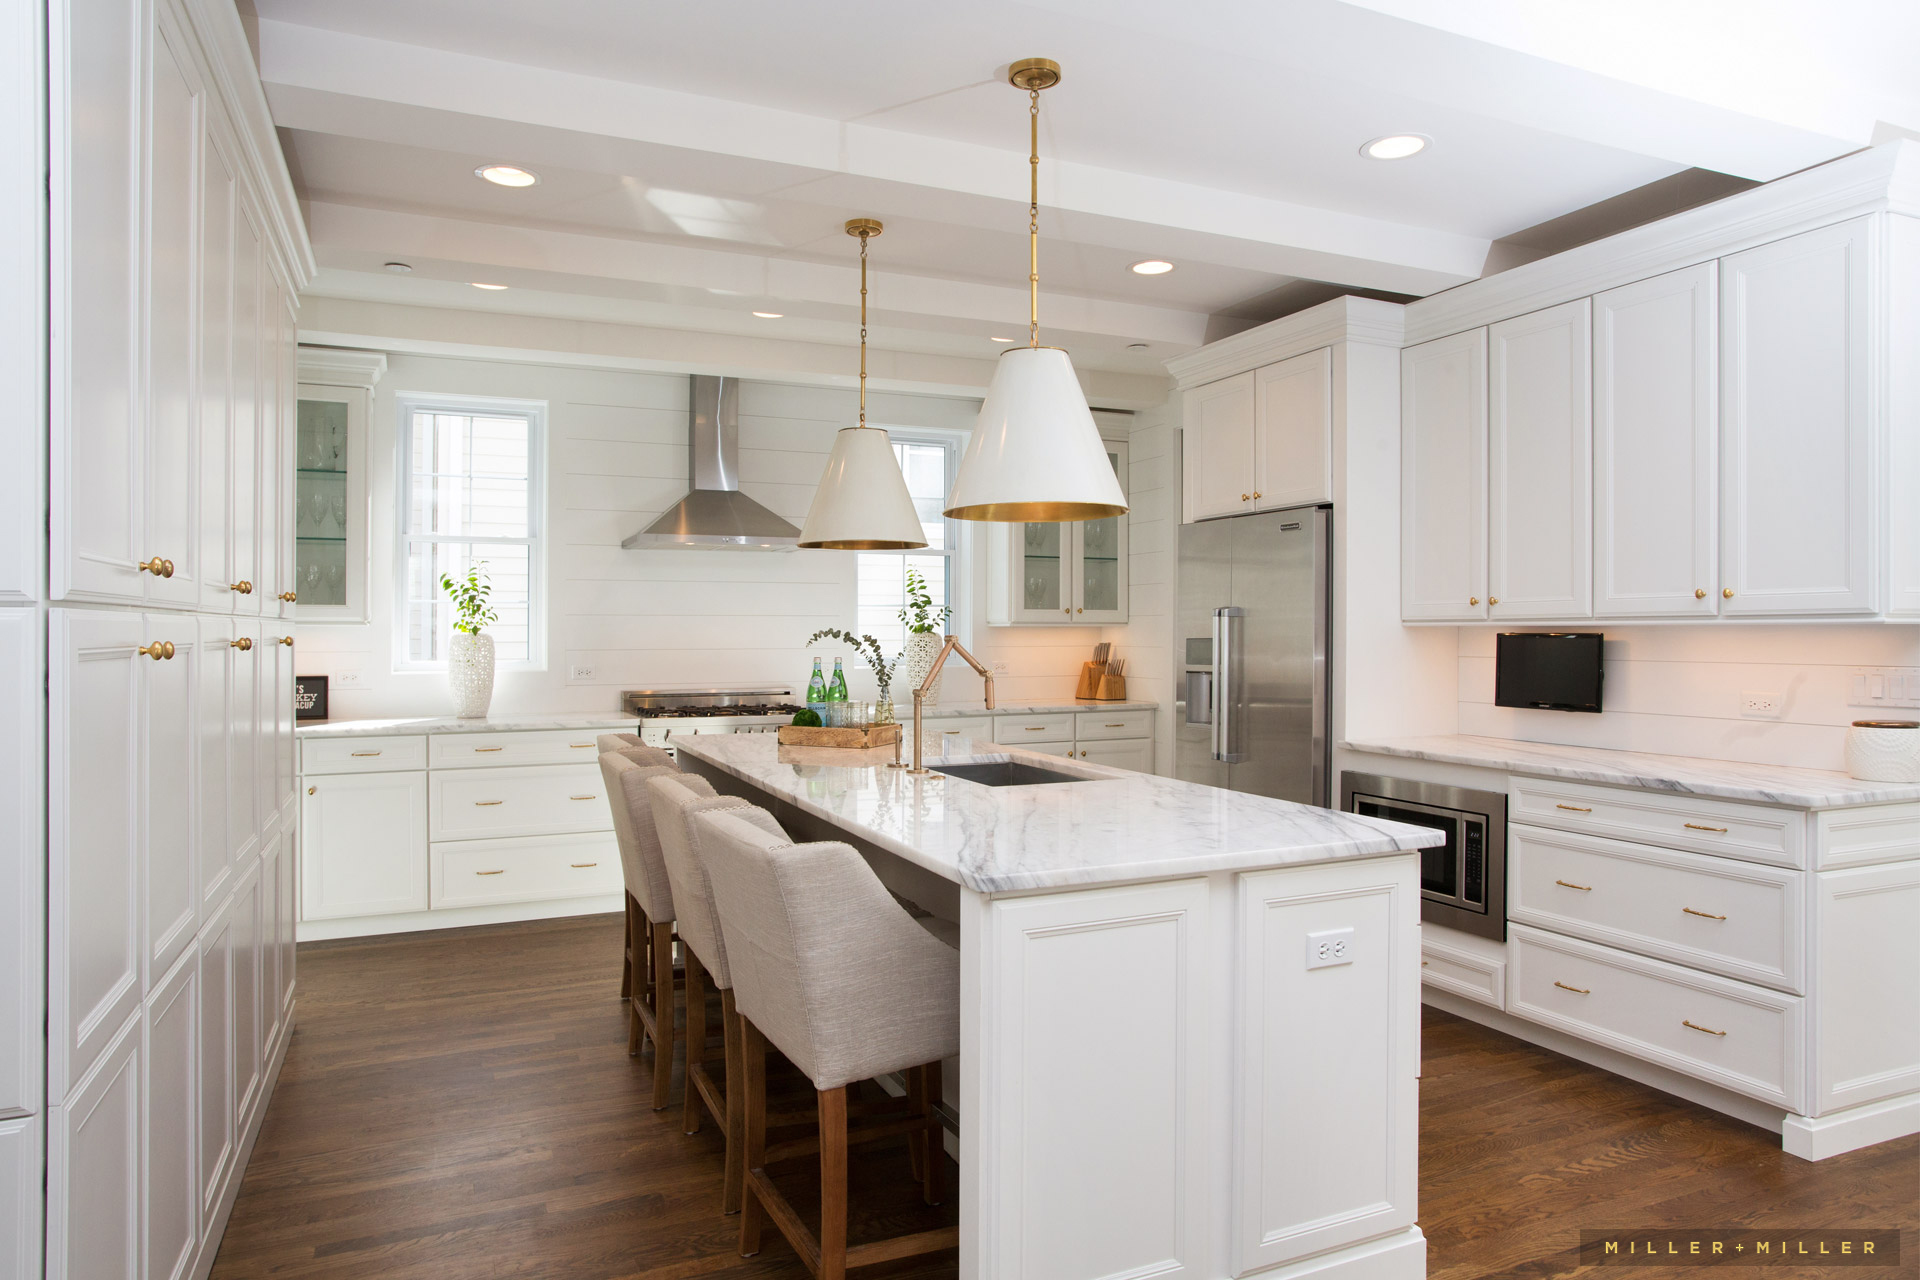What are the possible advantages of having the range hood in the design and position it is in? The range hood, strategically positioned directly above the cooktop, offers numerous advantages. Its generous size ensures it efficiently captures smoke, steam, and cooking odors, which is vital for maintaining a clean and pleasant environment, especially in an open-concept kitchen. The stainless steel construction not only adds durability but is also easy to clean, seamlessly complementing other kitchen appliances for a cohesive look. Additionally, placing the range hood against the wall allows for unobstructed space above the island, enhancing both lighting and the utility of the area for socializing and meal preparation. 